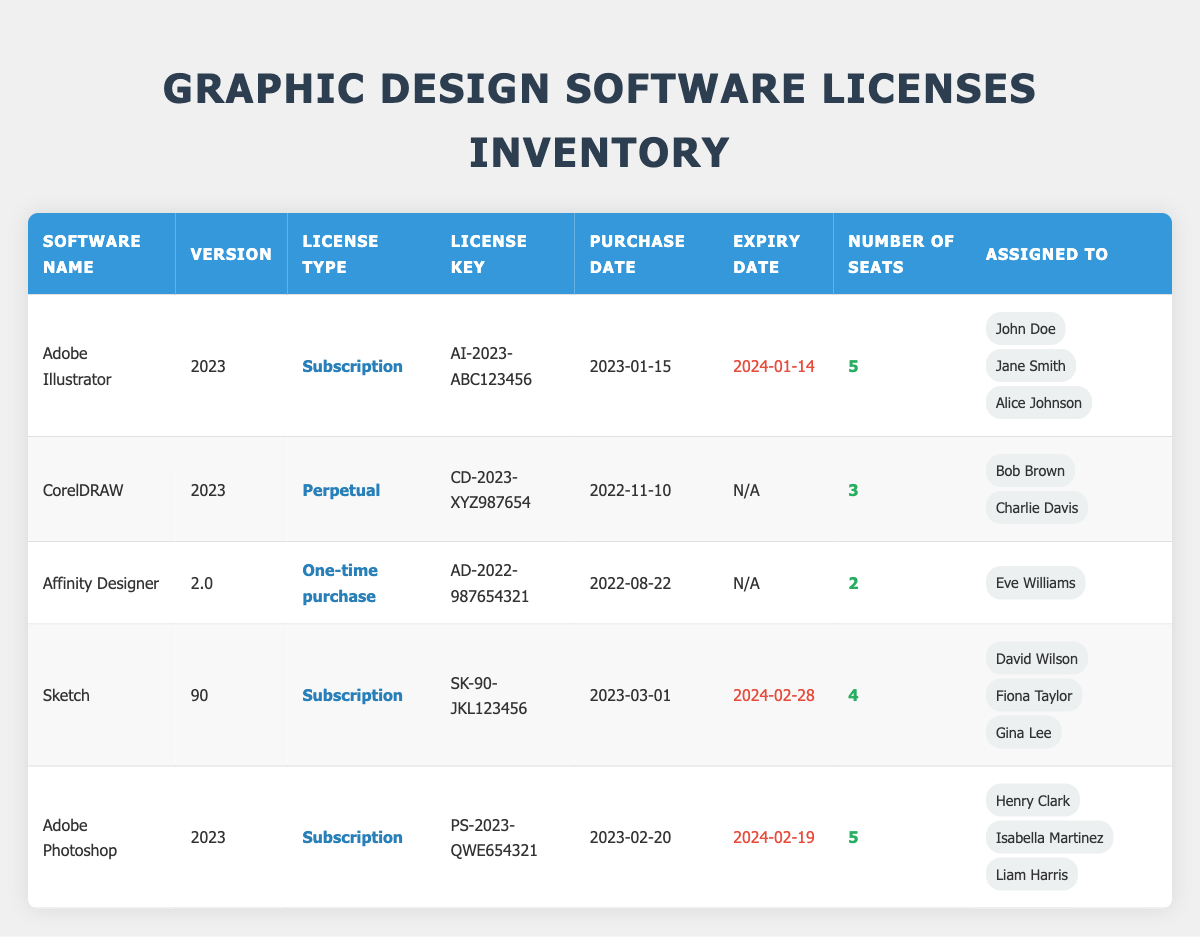What is the license type for Adobe Illustrator? The license type for Adobe Illustrator is listed in the table under the "License Type" column corresponding to the row for Adobe Illustrator. It states that the license type is "Subscription."
Answer: Subscription How many seats are available for Adobe Photoshop? To find the number of seats for Adobe Photoshop, we can look at the "Number of Seats" column for the row labeled Adobe Photoshop. It shows that there are 5 seats available.
Answer: 5 Which software has a perpetual license type? We look through the "License Type" column and identify which software has the type "Perpetual." In the table, CorelDRAW is the only software listed with this license type.
Answer: CorelDRAW How many total seats are assigned across all software? We need to sum up the "Number of Seats" for each software listed in the table: 5 (Adobe Illustrator) + 3 (CorelDRAW) + 2 (Affinity Designer) + 4 (Sketch) + 5 (Adobe Photoshop) = 19. Therefore, the total number of seats assigned is 19.
Answer: 19 Is Affinity Designer assigned to more than one user? By checking the "Assigned To" column for Affinity Designer, we see that there is only one user, Eve Williams assigned to it. Therefore, the answer is no.
Answer: No Which software has the nearest expiry date, and what is that date? We check the "Expiry Date" column for each row of software, noting that Adobe Illustrator expires on 2024-01-14, and Adobe Photoshop on 2024-02-19. The earliest date is 2024-01-14 for Adobe Illustrator.
Answer: Adobe Illustrator, 2024-01-14 What percentage of licenses are one-time purchases? There are three different license types: Subscription, Perpetual, and One-time purchase. There is only one license that is a one-time purchase (Affinity Designer) out of a total of five licenses. The percentage is (1/5) * 100 = 20%.
Answer: 20% How many licenses were purchased in 2023? We need to identify which licenses have a purchase date in 2023, which includes Adobe Illustrator (2023-01-15), Sketch (2023-03-01), and Adobe Photoshop (2023-02-20). This totals three licenses purchased in 2023.
Answer: 3 Are all users assigned seats for software with an expiry date listed? To answer this, we look for software with expiry dates and check if all have users listed. Adobe Illustrator, Sketch, and Adobe Photoshop have expiry dates and all have assigned users, while CorelDRAW and Affinity Designer do not list expiry dates. Therefore, the answer is yes for those with expiry dates.
Answer: Yes 